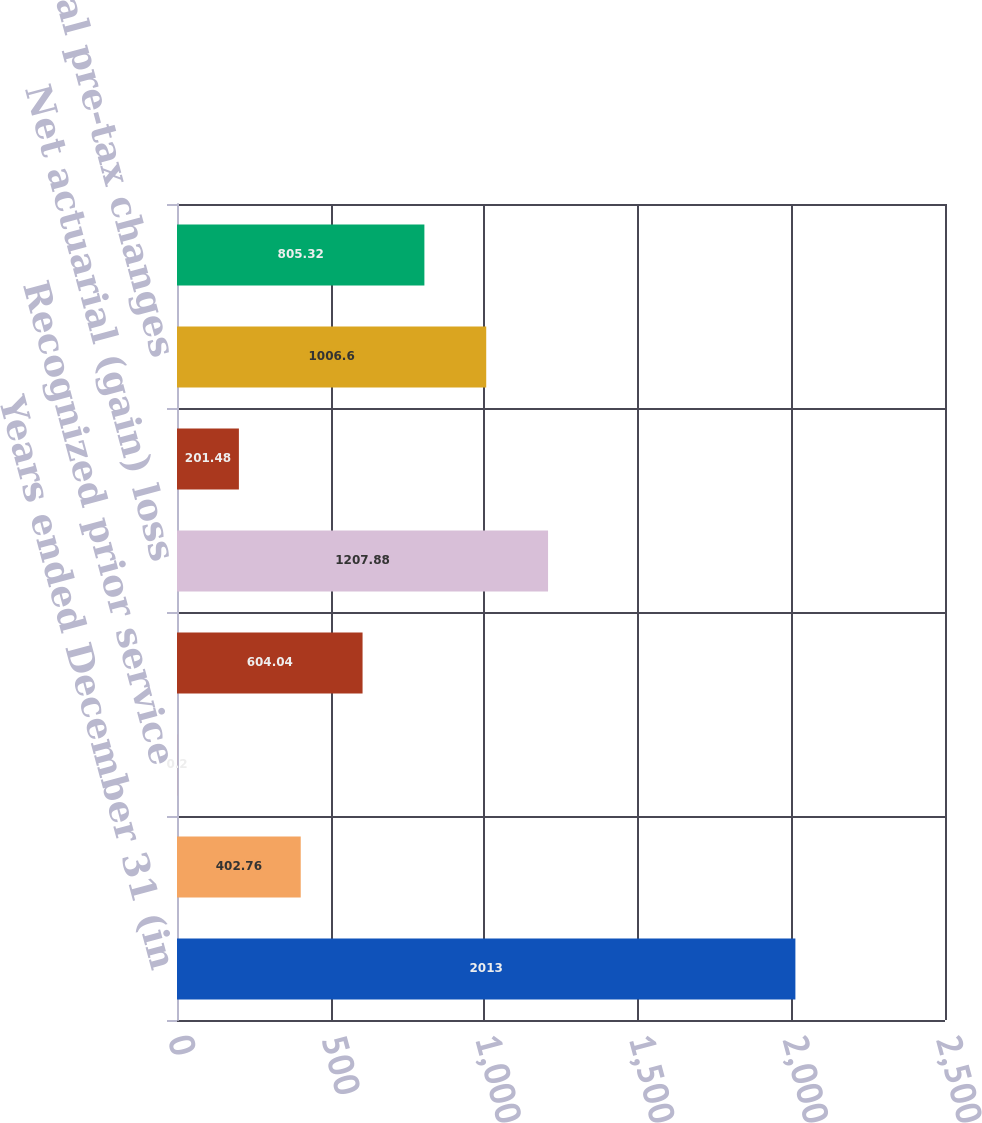<chart> <loc_0><loc_0><loc_500><loc_500><bar_chart><fcel>Years ended December 31 (in<fcel>Interest cost<fcel>Recognized prior service<fcel>Net periodic benefit (income)<fcel>Net actuarial (gain) loss<fcel>Prior service credit<fcel>Total pre-tax changes<fcel>Total recognized in net<nl><fcel>2013<fcel>402.76<fcel>0.2<fcel>604.04<fcel>1207.88<fcel>201.48<fcel>1006.6<fcel>805.32<nl></chart> 